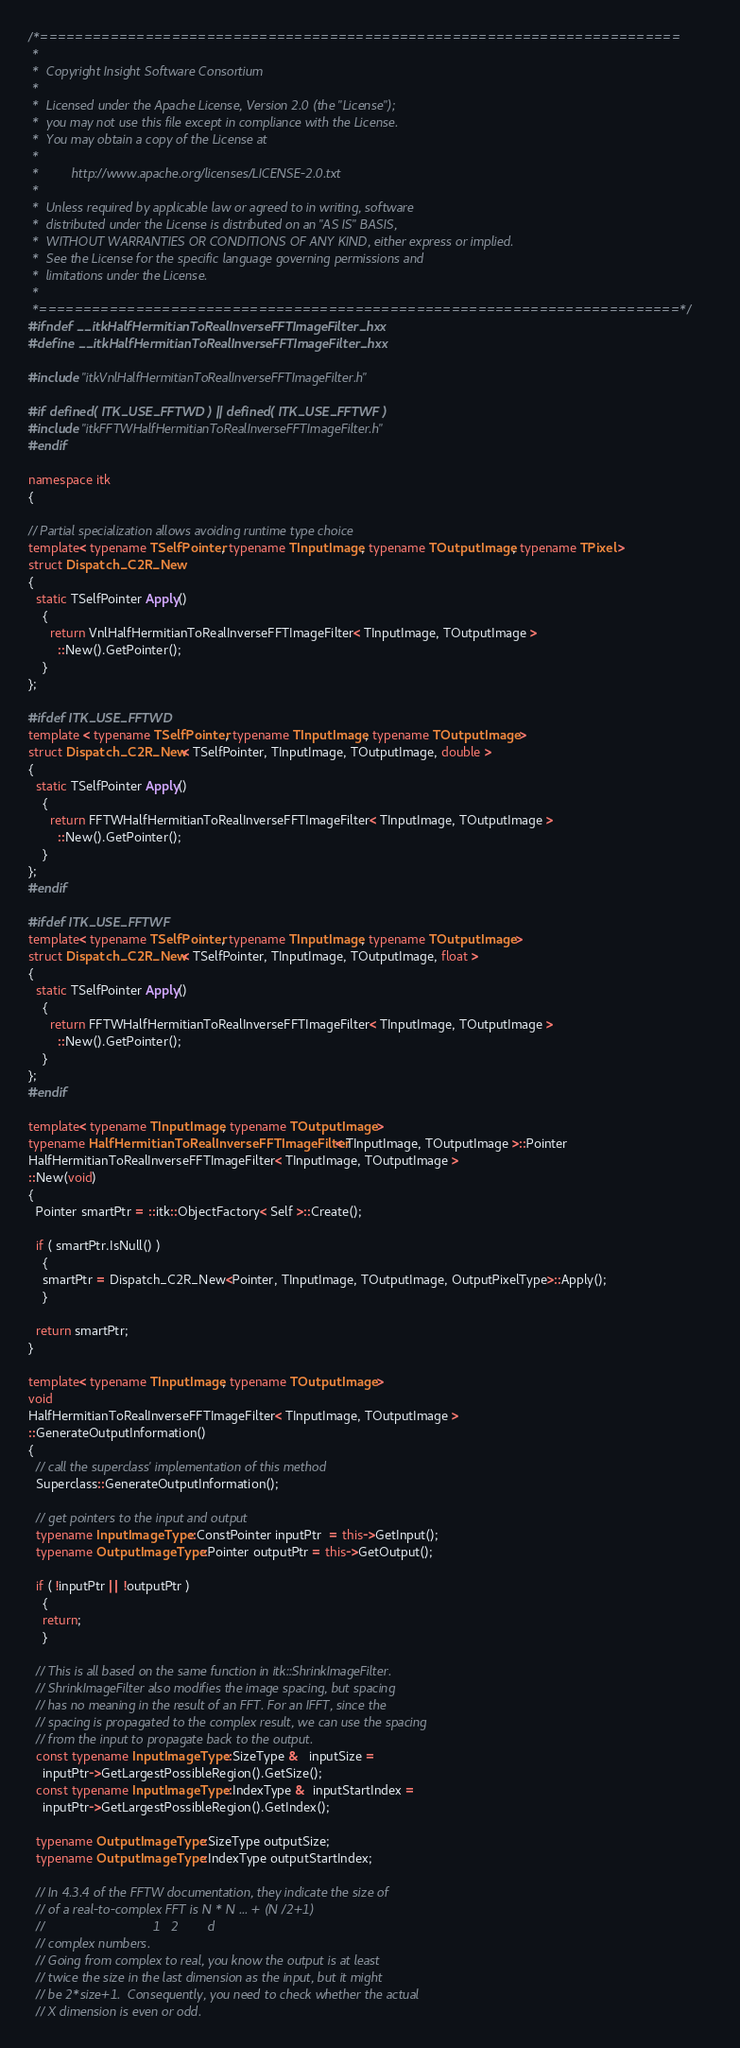Convert code to text. <code><loc_0><loc_0><loc_500><loc_500><_C++_>/*=========================================================================
 *
 *  Copyright Insight Software Consortium
 *
 *  Licensed under the Apache License, Version 2.0 (the "License");
 *  you may not use this file except in compliance with the License.
 *  You may obtain a copy of the License at
 *
 *         http://www.apache.org/licenses/LICENSE-2.0.txt
 *
 *  Unless required by applicable law or agreed to in writing, software
 *  distributed under the License is distributed on an "AS IS" BASIS,
 *  WITHOUT WARRANTIES OR CONDITIONS OF ANY KIND, either express or implied.
 *  See the License for the specific language governing permissions and
 *  limitations under the License.
 *
 *=========================================================================*/
#ifndef __itkHalfHermitianToRealInverseFFTImageFilter_hxx
#define __itkHalfHermitianToRealInverseFFTImageFilter_hxx

#include "itkVnlHalfHermitianToRealInverseFFTImageFilter.h"

#if defined( ITK_USE_FFTWD ) || defined( ITK_USE_FFTWF )
#include "itkFFTWHalfHermitianToRealInverseFFTImageFilter.h"
#endif

namespace itk
{

// Partial specialization allows avoiding runtime type choice
template< typename TSelfPointer, typename TInputImage, typename TOutputImage, typename TPixel >
struct Dispatch_C2R_New
{
  static TSelfPointer Apply()
    {
      return VnlHalfHermitianToRealInverseFFTImageFilter< TInputImage, TOutputImage >
        ::New().GetPointer();
    }
};

#ifdef ITK_USE_FFTWD
template < typename TSelfPointer, typename TInputImage, typename TOutputImage >
struct Dispatch_C2R_New< TSelfPointer, TInputImage, TOutputImage, double >
{
  static TSelfPointer Apply()
    {
      return FFTWHalfHermitianToRealInverseFFTImageFilter< TInputImage, TOutputImage >
        ::New().GetPointer();
    }
};
#endif

#ifdef ITK_USE_FFTWF
template< typename TSelfPointer, typename TInputImage, typename TOutputImage >
struct Dispatch_C2R_New< TSelfPointer, TInputImage, TOutputImage, float >
{
  static TSelfPointer Apply()
    {
      return FFTWHalfHermitianToRealInverseFFTImageFilter< TInputImage, TOutputImage >
        ::New().GetPointer();
    }
};
#endif

template< typename TInputImage, typename TOutputImage >
typename HalfHermitianToRealInverseFFTImageFilter< TInputImage, TOutputImage >::Pointer
HalfHermitianToRealInverseFFTImageFilter< TInputImage, TOutputImage >
::New(void)
{
  Pointer smartPtr = ::itk::ObjectFactory< Self >::Create();

  if ( smartPtr.IsNull() )
    {
    smartPtr = Dispatch_C2R_New<Pointer, TInputImage, TOutputImage, OutputPixelType>::Apply();
    }

  return smartPtr;
}

template< typename TInputImage, typename TOutputImage >
void
HalfHermitianToRealInverseFFTImageFilter< TInputImage, TOutputImage >
::GenerateOutputInformation()
{
  // call the superclass' implementation of this method
  Superclass::GenerateOutputInformation();

  // get pointers to the input and output
  typename InputImageType::ConstPointer inputPtr  = this->GetInput();
  typename OutputImageType::Pointer outputPtr = this->GetOutput();

  if ( !inputPtr || !outputPtr )
    {
    return;
    }

  // This is all based on the same function in itk::ShrinkImageFilter.
  // ShrinkImageFilter also modifies the image spacing, but spacing
  // has no meaning in the result of an FFT. For an IFFT, since the
  // spacing is propagated to the complex result, we can use the spacing
  // from the input to propagate back to the output.
  const typename InputImageType::SizeType &   inputSize =
    inputPtr->GetLargestPossibleRegion().GetSize();
  const typename InputImageType::IndexType &  inputStartIndex =
    inputPtr->GetLargestPossibleRegion().GetIndex();

  typename OutputImageType::SizeType outputSize;
  typename OutputImageType::IndexType outputStartIndex;

  // In 4.3.4 of the FFTW documentation, they indicate the size of
  // of a real-to-complex FFT is N * N ... + (N /2+1)
  //                              1   2        d
  // complex numbers.
  // Going from complex to real, you know the output is at least
  // twice the size in the last dimension as the input, but it might
  // be 2*size+1.  Consequently, you need to check whether the actual
  // X dimension is even or odd.</code> 